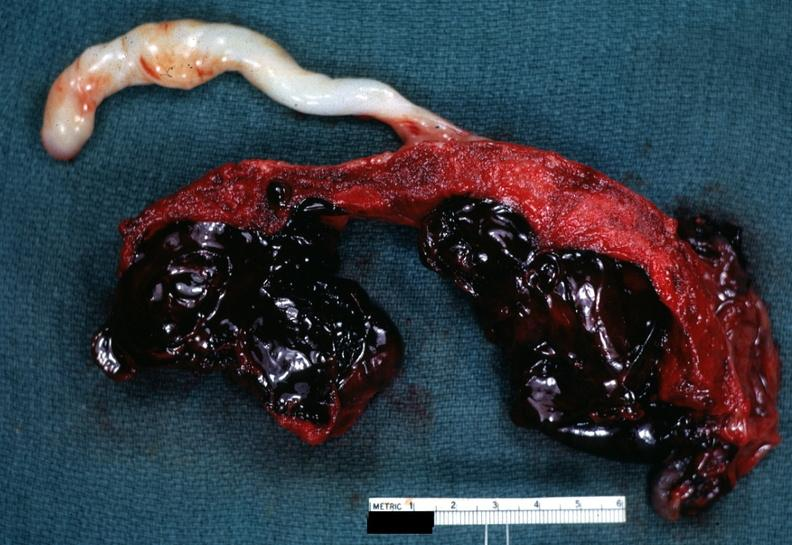what is present?
Answer the question using a single word or phrase. Female reproductive 